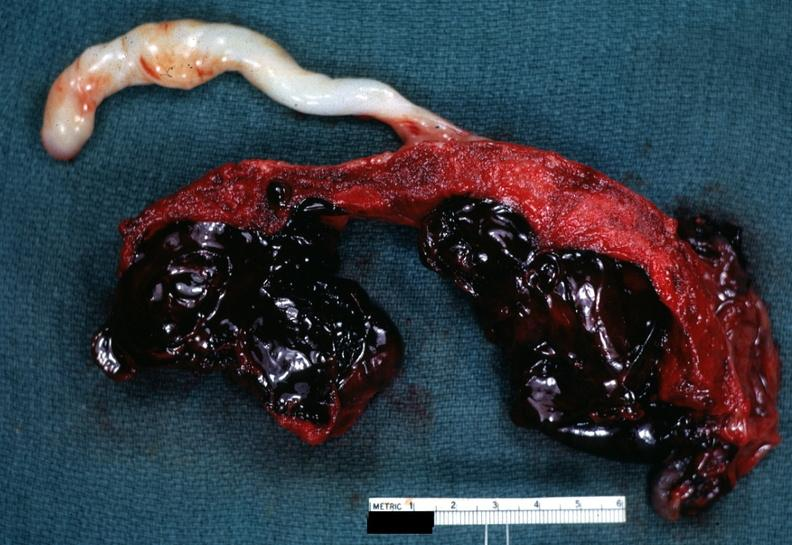what is present?
Answer the question using a single word or phrase. Female reproductive 